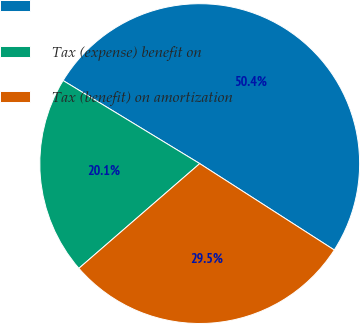Convert chart to OTSL. <chart><loc_0><loc_0><loc_500><loc_500><pie_chart><ecel><fcel>Tax (expense) benefit on<fcel>Tax (benefit) on amortization<nl><fcel>50.39%<fcel>20.06%<fcel>29.55%<nl></chart> 